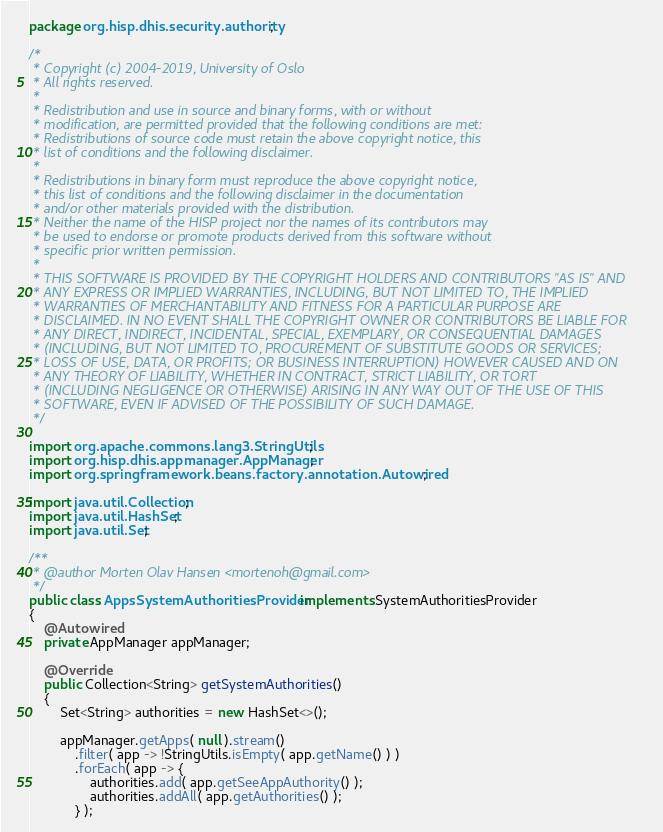Convert code to text. <code><loc_0><loc_0><loc_500><loc_500><_Java_>package org.hisp.dhis.security.authority;

/*
 * Copyright (c) 2004-2019, University of Oslo
 * All rights reserved.
 *
 * Redistribution and use in source and binary forms, with or without
 * modification, are permitted provided that the following conditions are met:
 * Redistributions of source code must retain the above copyright notice, this
 * list of conditions and the following disclaimer.
 *
 * Redistributions in binary form must reproduce the above copyright notice,
 * this list of conditions and the following disclaimer in the documentation
 * and/or other materials provided with the distribution.
 * Neither the name of the HISP project nor the names of its contributors may
 * be used to endorse or promote products derived from this software without
 * specific prior written permission.
 *
 * THIS SOFTWARE IS PROVIDED BY THE COPYRIGHT HOLDERS AND CONTRIBUTORS "AS IS" AND
 * ANY EXPRESS OR IMPLIED WARRANTIES, INCLUDING, BUT NOT LIMITED TO, THE IMPLIED
 * WARRANTIES OF MERCHANTABILITY AND FITNESS FOR A PARTICULAR PURPOSE ARE
 * DISCLAIMED. IN NO EVENT SHALL THE COPYRIGHT OWNER OR CONTRIBUTORS BE LIABLE FOR
 * ANY DIRECT, INDIRECT, INCIDENTAL, SPECIAL, EXEMPLARY, OR CONSEQUENTIAL DAMAGES
 * (INCLUDING, BUT NOT LIMITED TO, PROCUREMENT OF SUBSTITUTE GOODS OR SERVICES;
 * LOSS OF USE, DATA, OR PROFITS; OR BUSINESS INTERRUPTION) HOWEVER CAUSED AND ON
 * ANY THEORY OF LIABILITY, WHETHER IN CONTRACT, STRICT LIABILITY, OR TORT
 * (INCLUDING NEGLIGENCE OR OTHERWISE) ARISING IN ANY WAY OUT OF THE USE OF THIS
 * SOFTWARE, EVEN IF ADVISED OF THE POSSIBILITY OF SUCH DAMAGE.
 */

import org.apache.commons.lang3.StringUtils;
import org.hisp.dhis.appmanager.AppManager;
import org.springframework.beans.factory.annotation.Autowired;

import java.util.Collection;
import java.util.HashSet;
import java.util.Set;

/**
 * @author Morten Olav Hansen <mortenoh@gmail.com>
 */
public class AppsSystemAuthoritiesProvider implements SystemAuthoritiesProvider
{
    @Autowired
    private AppManager appManager;

    @Override
    public Collection<String> getSystemAuthorities()
    {
        Set<String> authorities = new HashSet<>();

        appManager.getApps( null ).stream()
            .filter( app -> !StringUtils.isEmpty( app.getName() ) )
            .forEach( app -> {
                authorities.add( app.getSeeAppAuthority() );
                authorities.addAll( app.getAuthorities() );
            } );
</code> 